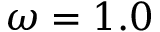Convert formula to latex. <formula><loc_0><loc_0><loc_500><loc_500>\omega = 1 . 0</formula> 